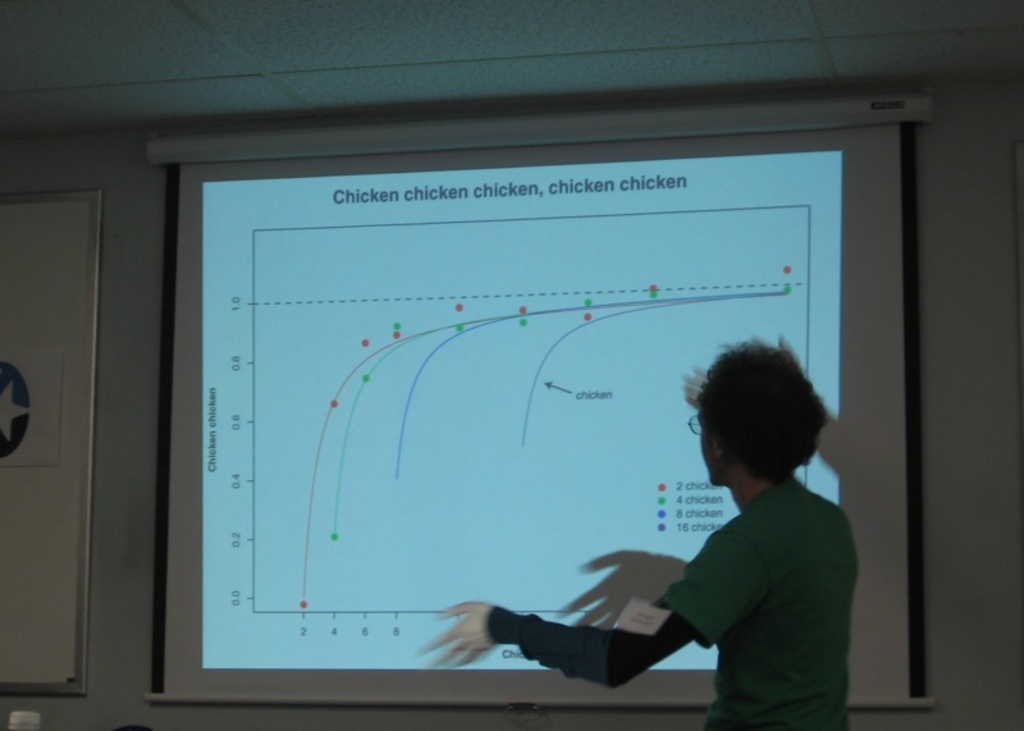Provide a one-sentence caption for the provided image.
Reference OCR token: Chicken, chicken, chicken, chicken, chicken A person is explaining a chart projected on the wall about chicken. 